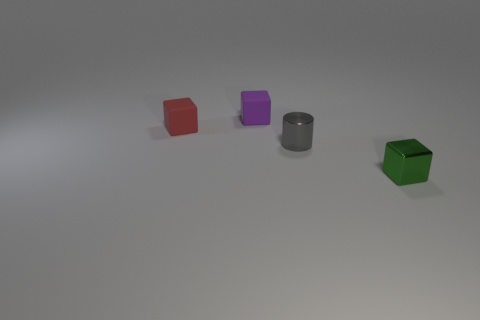Subtract all tiny green cubes. How many cubes are left? 2 Add 3 big gray matte balls. How many objects exist? 7 Subtract 1 cylinders. How many cylinders are left? 0 Subtract all purple cubes. How many cubes are left? 2 Subtract all cylinders. How many objects are left? 3 Subtract all red cylinders. Subtract all brown cubes. How many cylinders are left? 1 Subtract all cyan balls. How many brown cylinders are left? 0 Subtract all red rubber objects. Subtract all tiny matte objects. How many objects are left? 1 Add 3 small purple blocks. How many small purple blocks are left? 4 Add 1 tiny green things. How many tiny green things exist? 2 